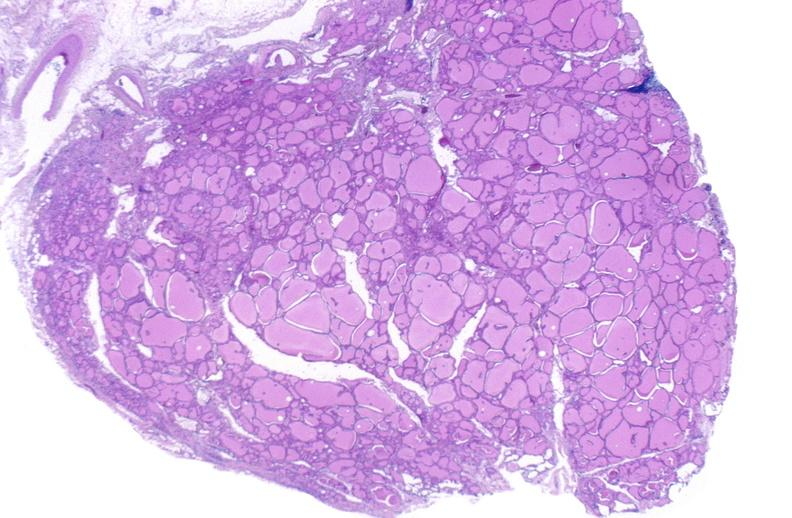what does this image show?
Answer the question using a single word or phrase. Thyroid gland 